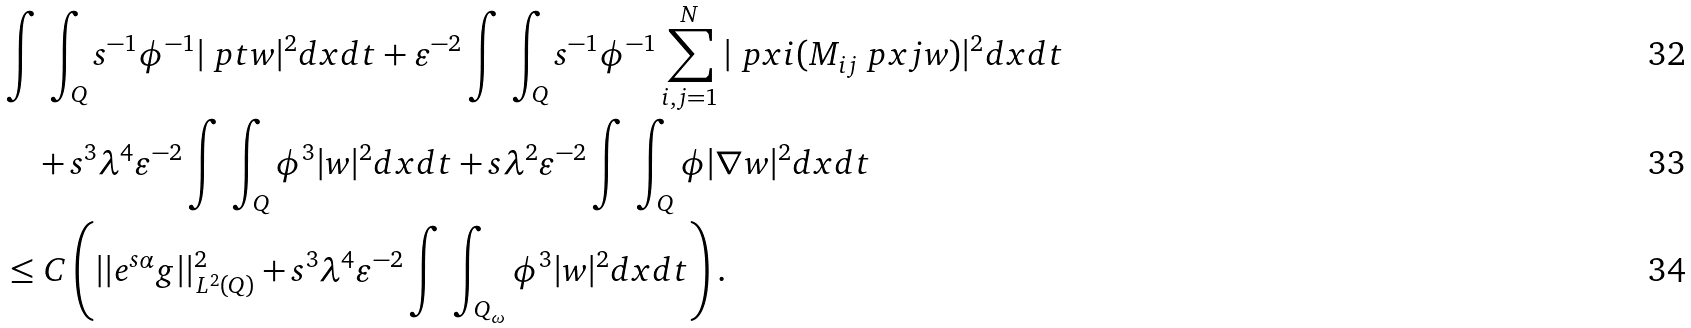Convert formula to latex. <formula><loc_0><loc_0><loc_500><loc_500>& \int \, \int _ { Q } s ^ { - 1 } \phi ^ { - 1 } | \ p t w | ^ { 2 } d x d t + \varepsilon ^ { - 2 } \int \, \int _ { Q } s ^ { - 1 } \phi ^ { - 1 } \sum _ { i , j = 1 } ^ { N } | \ p x i ( M _ { i j } \ p x j w ) | ^ { 2 } d x d t \\ & \quad + s ^ { 3 } \lambda ^ { 4 } \varepsilon ^ { - 2 } \int \, \int _ { Q } \phi ^ { 3 } | w | ^ { 2 } d x d t + s \lambda ^ { 2 } \varepsilon ^ { - 2 } \int \, \int _ { Q } \phi | \nabla w | ^ { 2 } d x d t \\ & \leq C \left ( | | e ^ { s \alpha } g | | _ { L ^ { 2 } ( Q ) } ^ { 2 } + s ^ { 3 } \lambda ^ { 4 } \varepsilon ^ { - 2 } \int \, \int _ { Q _ { \omega } } \phi ^ { 3 } | w | ^ { 2 } d x d t \right ) .</formula> 